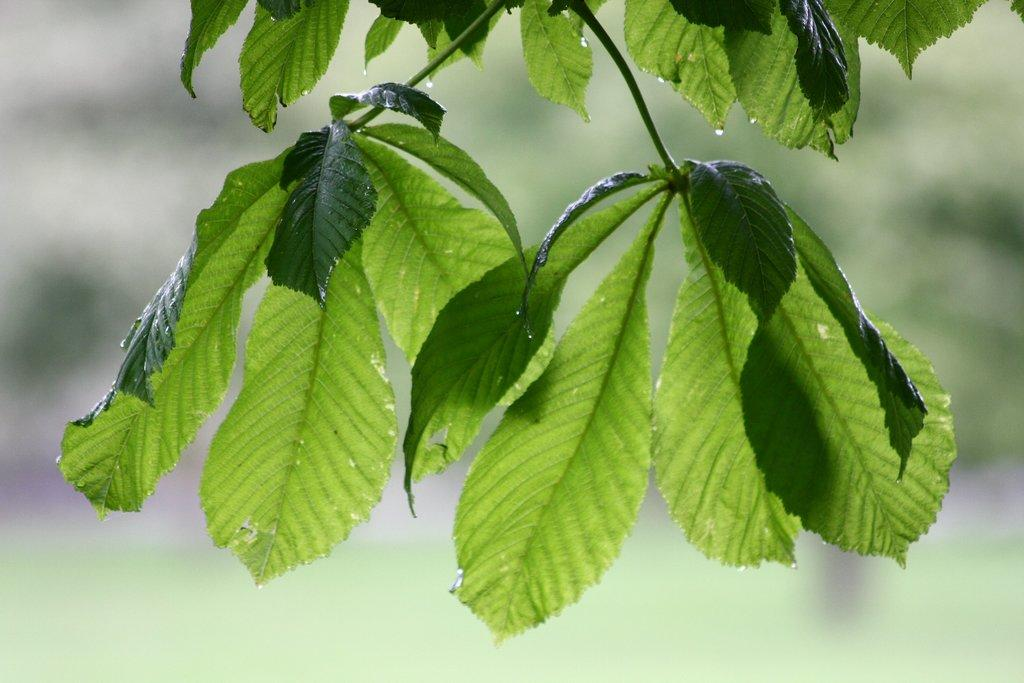What type of vegetation is present in the image? There are green leaves in the image. What natural element can be seen in the image? Water is visible in the image. What colors are present in the background of the image? The background of the image includes white and green colors. What grade does the wheel receive in the image? There is no wheel present in the image, so it cannot receive a grade. 